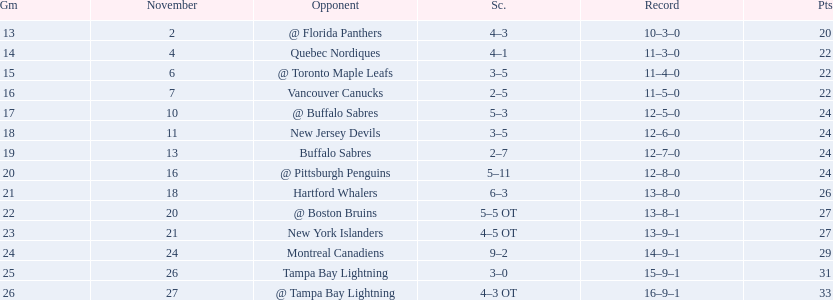What was the total penalty minutes that dave brown had on the 1993-1994 flyers? 137. 